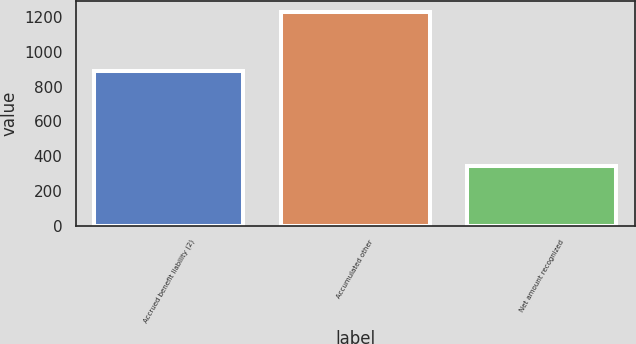Convert chart. <chart><loc_0><loc_0><loc_500><loc_500><bar_chart><fcel>Accrued benefit liability (2)<fcel>Accumulated other<fcel>Net amount recognized<nl><fcel>889<fcel>1231<fcel>342<nl></chart> 